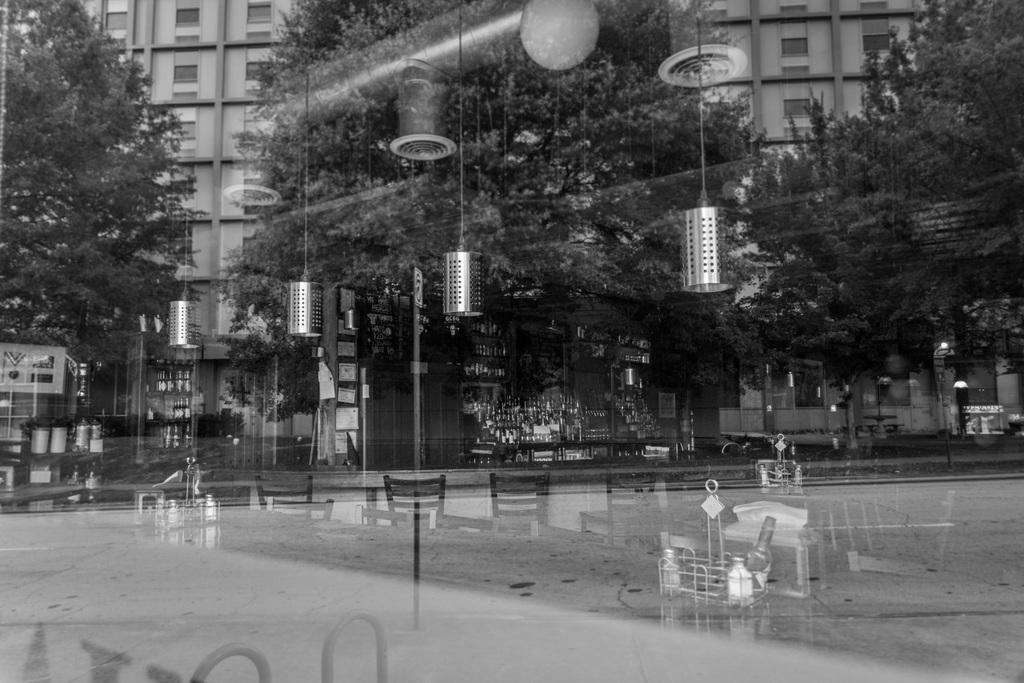What is the color scheme of the image? The image is black and white. What can be seen reflected in the image? There is a reflection of a building in the image. What type of natural vegetation is visible in the image? Trees are visible in the image. What type of furniture is present in the image? Chairs are present in the image. What can be seen through the transparent glass in the image? There are other objects visible in the image through the transparent glass. Where is the toothbrush placed in the image? There is no toothbrush present in the image. What type of sofa can be seen in the image? There is no sofa present in the image. 